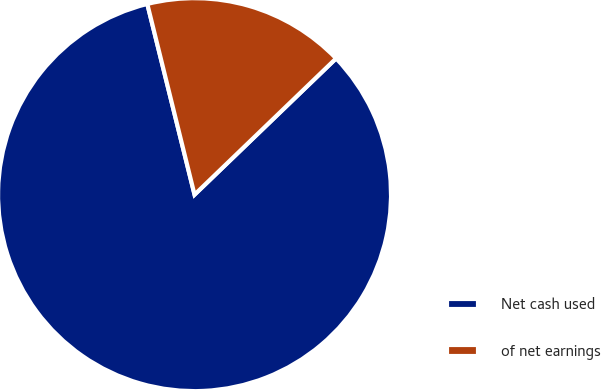Convert chart. <chart><loc_0><loc_0><loc_500><loc_500><pie_chart><fcel>Net cash used<fcel>of net earnings<nl><fcel>83.33%<fcel>16.67%<nl></chart> 